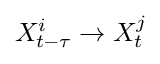Convert formula to latex. <formula><loc_0><loc_0><loc_500><loc_500>X _ { t - \tau } ^ { i } \rightarrow X _ { t } ^ { j }</formula> 